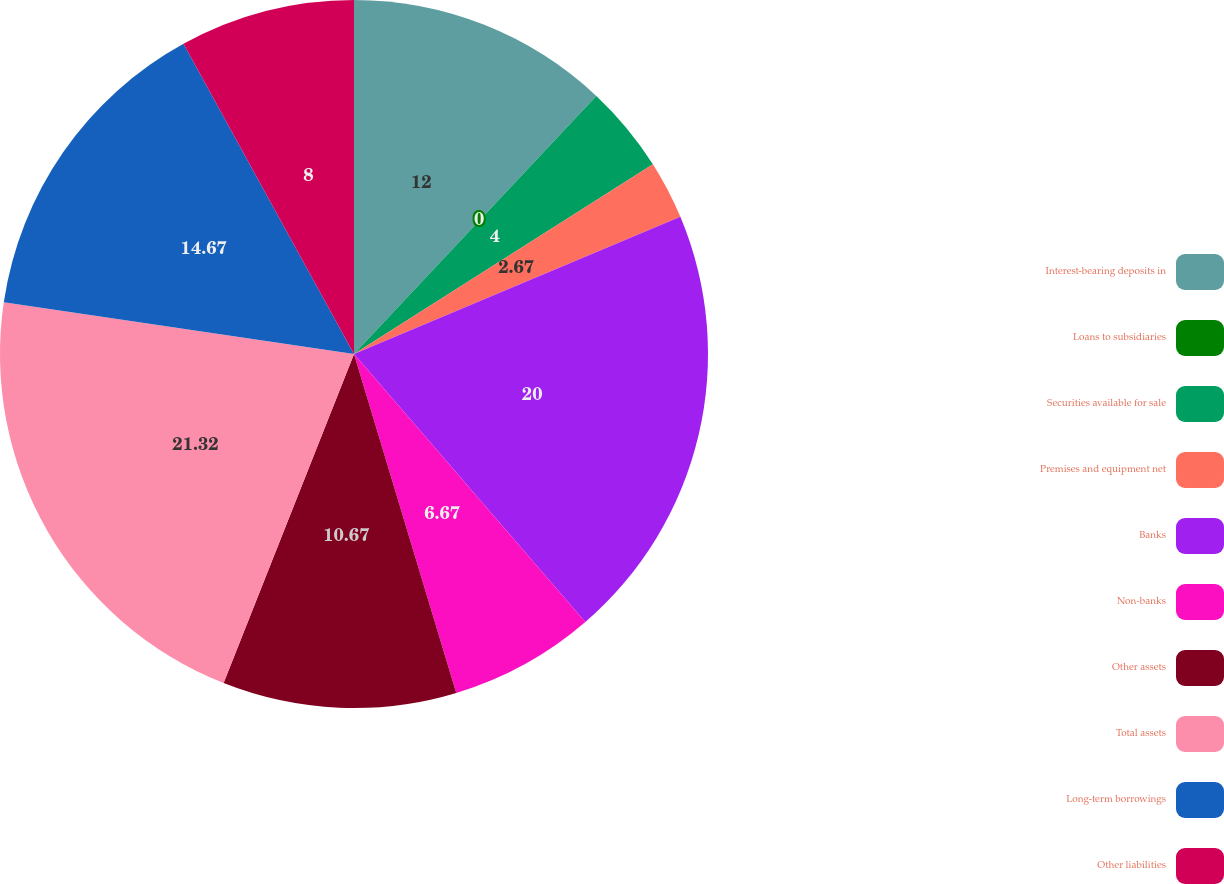Convert chart. <chart><loc_0><loc_0><loc_500><loc_500><pie_chart><fcel>Interest-bearing deposits in<fcel>Loans to subsidiaries<fcel>Securities available for sale<fcel>Premises and equipment net<fcel>Banks<fcel>Non-banks<fcel>Other assets<fcel>Total assets<fcel>Long-term borrowings<fcel>Other liabilities<nl><fcel>12.0%<fcel>0.0%<fcel>4.0%<fcel>2.67%<fcel>20.0%<fcel>6.67%<fcel>10.67%<fcel>21.33%<fcel>14.67%<fcel>8.0%<nl></chart> 